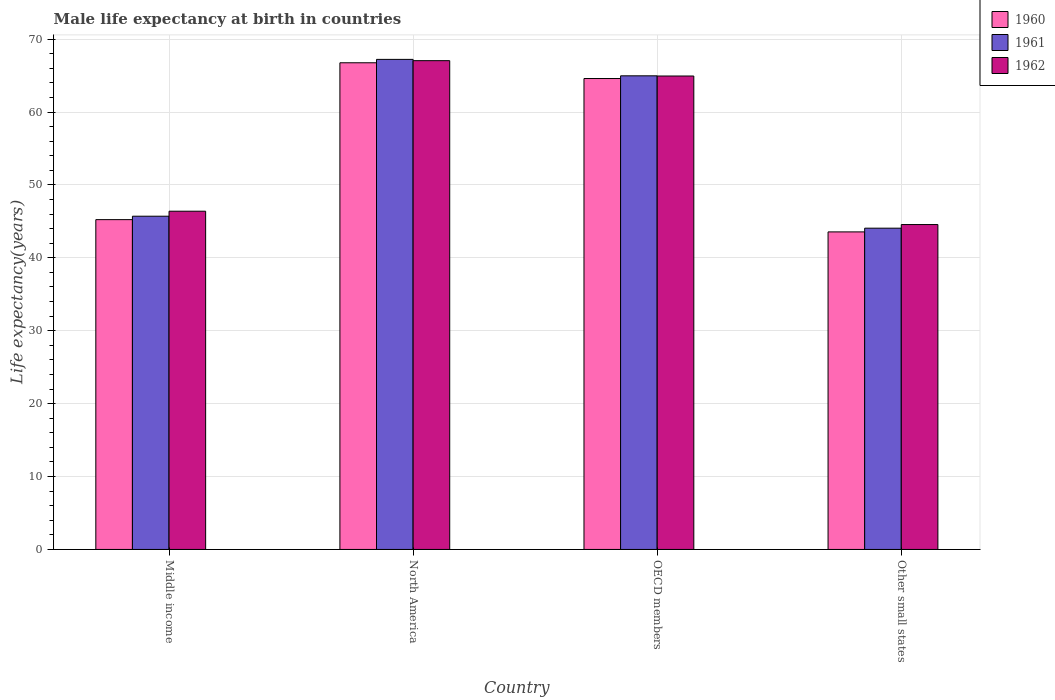How many groups of bars are there?
Make the answer very short. 4. Are the number of bars on each tick of the X-axis equal?
Provide a succinct answer. Yes. How many bars are there on the 1st tick from the left?
Ensure brevity in your answer.  3. How many bars are there on the 4th tick from the right?
Offer a very short reply. 3. What is the label of the 4th group of bars from the left?
Your answer should be very brief. Other small states. What is the male life expectancy at birth in 1961 in OECD members?
Offer a terse response. 64.96. Across all countries, what is the maximum male life expectancy at birth in 1960?
Make the answer very short. 66.75. Across all countries, what is the minimum male life expectancy at birth in 1961?
Your response must be concise. 44.07. In which country was the male life expectancy at birth in 1962 maximum?
Your response must be concise. North America. In which country was the male life expectancy at birth in 1962 minimum?
Provide a short and direct response. Other small states. What is the total male life expectancy at birth in 1960 in the graph?
Your response must be concise. 220.14. What is the difference between the male life expectancy at birth in 1961 in Middle income and that in OECD members?
Provide a short and direct response. -19.26. What is the difference between the male life expectancy at birth in 1961 in North America and the male life expectancy at birth in 1962 in Other small states?
Your answer should be compact. 22.66. What is the average male life expectancy at birth in 1962 per country?
Offer a terse response. 55.73. What is the difference between the male life expectancy at birth of/in 1961 and male life expectancy at birth of/in 1960 in OECD members?
Provide a succinct answer. 0.37. In how many countries, is the male life expectancy at birth in 1961 greater than 30 years?
Give a very brief answer. 4. What is the ratio of the male life expectancy at birth in 1960 in Middle income to that in OECD members?
Make the answer very short. 0.7. Is the difference between the male life expectancy at birth in 1961 in Middle income and Other small states greater than the difference between the male life expectancy at birth in 1960 in Middle income and Other small states?
Your answer should be compact. No. What is the difference between the highest and the second highest male life expectancy at birth in 1961?
Your response must be concise. -2.25. What is the difference between the highest and the lowest male life expectancy at birth in 1961?
Offer a terse response. 23.15. In how many countries, is the male life expectancy at birth in 1960 greater than the average male life expectancy at birth in 1960 taken over all countries?
Your answer should be compact. 2. Is the sum of the male life expectancy at birth in 1962 in North America and OECD members greater than the maximum male life expectancy at birth in 1960 across all countries?
Your response must be concise. Yes. What does the 3rd bar from the right in Middle income represents?
Provide a succinct answer. 1960. Is it the case that in every country, the sum of the male life expectancy at birth in 1961 and male life expectancy at birth in 1962 is greater than the male life expectancy at birth in 1960?
Make the answer very short. Yes. Are all the bars in the graph horizontal?
Provide a short and direct response. No. What is the difference between two consecutive major ticks on the Y-axis?
Offer a terse response. 10. Does the graph contain grids?
Offer a terse response. Yes. Where does the legend appear in the graph?
Your response must be concise. Top right. How many legend labels are there?
Make the answer very short. 3. What is the title of the graph?
Provide a succinct answer. Male life expectancy at birth in countries. What is the label or title of the X-axis?
Keep it short and to the point. Country. What is the label or title of the Y-axis?
Your response must be concise. Life expectancy(years). What is the Life expectancy(years) in 1960 in Middle income?
Provide a short and direct response. 45.24. What is the Life expectancy(years) of 1961 in Middle income?
Offer a terse response. 45.71. What is the Life expectancy(years) of 1962 in Middle income?
Your answer should be compact. 46.39. What is the Life expectancy(years) in 1960 in North America?
Keep it short and to the point. 66.75. What is the Life expectancy(years) in 1961 in North America?
Offer a terse response. 67.22. What is the Life expectancy(years) of 1962 in North America?
Your answer should be very brief. 67.04. What is the Life expectancy(years) in 1960 in OECD members?
Offer a very short reply. 64.59. What is the Life expectancy(years) in 1961 in OECD members?
Ensure brevity in your answer.  64.96. What is the Life expectancy(years) of 1962 in OECD members?
Make the answer very short. 64.94. What is the Life expectancy(years) of 1960 in Other small states?
Provide a succinct answer. 43.56. What is the Life expectancy(years) of 1961 in Other small states?
Ensure brevity in your answer.  44.07. What is the Life expectancy(years) in 1962 in Other small states?
Offer a terse response. 44.56. Across all countries, what is the maximum Life expectancy(years) in 1960?
Provide a succinct answer. 66.75. Across all countries, what is the maximum Life expectancy(years) of 1961?
Offer a terse response. 67.22. Across all countries, what is the maximum Life expectancy(years) in 1962?
Your response must be concise. 67.04. Across all countries, what is the minimum Life expectancy(years) of 1960?
Keep it short and to the point. 43.56. Across all countries, what is the minimum Life expectancy(years) of 1961?
Offer a very short reply. 44.07. Across all countries, what is the minimum Life expectancy(years) in 1962?
Offer a terse response. 44.56. What is the total Life expectancy(years) of 1960 in the graph?
Your answer should be very brief. 220.14. What is the total Life expectancy(years) of 1961 in the graph?
Provide a short and direct response. 221.96. What is the total Life expectancy(years) of 1962 in the graph?
Give a very brief answer. 222.94. What is the difference between the Life expectancy(years) in 1960 in Middle income and that in North America?
Provide a succinct answer. -21.51. What is the difference between the Life expectancy(years) in 1961 in Middle income and that in North America?
Provide a succinct answer. -21.51. What is the difference between the Life expectancy(years) in 1962 in Middle income and that in North America?
Your response must be concise. -20.65. What is the difference between the Life expectancy(years) in 1960 in Middle income and that in OECD members?
Keep it short and to the point. -19.35. What is the difference between the Life expectancy(years) in 1961 in Middle income and that in OECD members?
Provide a succinct answer. -19.26. What is the difference between the Life expectancy(years) in 1962 in Middle income and that in OECD members?
Make the answer very short. -18.54. What is the difference between the Life expectancy(years) of 1960 in Middle income and that in Other small states?
Offer a very short reply. 1.68. What is the difference between the Life expectancy(years) of 1961 in Middle income and that in Other small states?
Offer a terse response. 1.64. What is the difference between the Life expectancy(years) in 1962 in Middle income and that in Other small states?
Offer a terse response. 1.83. What is the difference between the Life expectancy(years) of 1960 in North America and that in OECD members?
Offer a terse response. 2.16. What is the difference between the Life expectancy(years) of 1961 in North America and that in OECD members?
Provide a short and direct response. 2.25. What is the difference between the Life expectancy(years) in 1962 in North America and that in OECD members?
Provide a short and direct response. 2.11. What is the difference between the Life expectancy(years) in 1960 in North America and that in Other small states?
Provide a succinct answer. 23.2. What is the difference between the Life expectancy(years) of 1961 in North America and that in Other small states?
Give a very brief answer. 23.15. What is the difference between the Life expectancy(years) of 1962 in North America and that in Other small states?
Give a very brief answer. 22.48. What is the difference between the Life expectancy(years) of 1960 in OECD members and that in Other small states?
Offer a terse response. 21.04. What is the difference between the Life expectancy(years) in 1961 in OECD members and that in Other small states?
Offer a terse response. 20.9. What is the difference between the Life expectancy(years) of 1962 in OECD members and that in Other small states?
Ensure brevity in your answer.  20.38. What is the difference between the Life expectancy(years) of 1960 in Middle income and the Life expectancy(years) of 1961 in North America?
Offer a very short reply. -21.98. What is the difference between the Life expectancy(years) in 1960 in Middle income and the Life expectancy(years) in 1962 in North America?
Make the answer very short. -21.8. What is the difference between the Life expectancy(years) in 1961 in Middle income and the Life expectancy(years) in 1962 in North America?
Keep it short and to the point. -21.34. What is the difference between the Life expectancy(years) of 1960 in Middle income and the Life expectancy(years) of 1961 in OECD members?
Your answer should be compact. -19.72. What is the difference between the Life expectancy(years) in 1960 in Middle income and the Life expectancy(years) in 1962 in OECD members?
Provide a short and direct response. -19.7. What is the difference between the Life expectancy(years) in 1961 in Middle income and the Life expectancy(years) in 1962 in OECD members?
Keep it short and to the point. -19.23. What is the difference between the Life expectancy(years) in 1960 in Middle income and the Life expectancy(years) in 1961 in Other small states?
Provide a succinct answer. 1.17. What is the difference between the Life expectancy(years) of 1960 in Middle income and the Life expectancy(years) of 1962 in Other small states?
Your response must be concise. 0.68. What is the difference between the Life expectancy(years) in 1961 in Middle income and the Life expectancy(years) in 1962 in Other small states?
Ensure brevity in your answer.  1.14. What is the difference between the Life expectancy(years) in 1960 in North America and the Life expectancy(years) in 1961 in OECD members?
Your answer should be compact. 1.79. What is the difference between the Life expectancy(years) of 1960 in North America and the Life expectancy(years) of 1962 in OECD members?
Keep it short and to the point. 1.82. What is the difference between the Life expectancy(years) in 1961 in North America and the Life expectancy(years) in 1962 in OECD members?
Offer a very short reply. 2.28. What is the difference between the Life expectancy(years) of 1960 in North America and the Life expectancy(years) of 1961 in Other small states?
Give a very brief answer. 22.69. What is the difference between the Life expectancy(years) in 1960 in North America and the Life expectancy(years) in 1962 in Other small states?
Make the answer very short. 22.19. What is the difference between the Life expectancy(years) of 1961 in North America and the Life expectancy(years) of 1962 in Other small states?
Keep it short and to the point. 22.66. What is the difference between the Life expectancy(years) in 1960 in OECD members and the Life expectancy(years) in 1961 in Other small states?
Offer a terse response. 20.53. What is the difference between the Life expectancy(years) of 1960 in OECD members and the Life expectancy(years) of 1962 in Other small states?
Offer a terse response. 20.03. What is the difference between the Life expectancy(years) of 1961 in OECD members and the Life expectancy(years) of 1962 in Other small states?
Provide a succinct answer. 20.4. What is the average Life expectancy(years) in 1960 per country?
Make the answer very short. 55.03. What is the average Life expectancy(years) in 1961 per country?
Your answer should be very brief. 55.49. What is the average Life expectancy(years) in 1962 per country?
Your answer should be compact. 55.73. What is the difference between the Life expectancy(years) in 1960 and Life expectancy(years) in 1961 in Middle income?
Keep it short and to the point. -0.47. What is the difference between the Life expectancy(years) in 1960 and Life expectancy(years) in 1962 in Middle income?
Keep it short and to the point. -1.15. What is the difference between the Life expectancy(years) of 1961 and Life expectancy(years) of 1962 in Middle income?
Offer a very short reply. -0.69. What is the difference between the Life expectancy(years) in 1960 and Life expectancy(years) in 1961 in North America?
Offer a very short reply. -0.47. What is the difference between the Life expectancy(years) in 1960 and Life expectancy(years) in 1962 in North America?
Give a very brief answer. -0.29. What is the difference between the Life expectancy(years) of 1961 and Life expectancy(years) of 1962 in North America?
Your response must be concise. 0.18. What is the difference between the Life expectancy(years) in 1960 and Life expectancy(years) in 1961 in OECD members?
Make the answer very short. -0.37. What is the difference between the Life expectancy(years) in 1960 and Life expectancy(years) in 1962 in OECD members?
Your answer should be very brief. -0.34. What is the difference between the Life expectancy(years) of 1961 and Life expectancy(years) of 1962 in OECD members?
Your answer should be compact. 0.03. What is the difference between the Life expectancy(years) of 1960 and Life expectancy(years) of 1961 in Other small states?
Give a very brief answer. -0.51. What is the difference between the Life expectancy(years) in 1960 and Life expectancy(years) in 1962 in Other small states?
Provide a succinct answer. -1.01. What is the difference between the Life expectancy(years) of 1961 and Life expectancy(years) of 1962 in Other small states?
Offer a terse response. -0.5. What is the ratio of the Life expectancy(years) in 1960 in Middle income to that in North America?
Your answer should be compact. 0.68. What is the ratio of the Life expectancy(years) in 1961 in Middle income to that in North America?
Your answer should be compact. 0.68. What is the ratio of the Life expectancy(years) of 1962 in Middle income to that in North America?
Provide a short and direct response. 0.69. What is the ratio of the Life expectancy(years) in 1960 in Middle income to that in OECD members?
Make the answer very short. 0.7. What is the ratio of the Life expectancy(years) of 1961 in Middle income to that in OECD members?
Offer a very short reply. 0.7. What is the ratio of the Life expectancy(years) in 1962 in Middle income to that in OECD members?
Your answer should be compact. 0.71. What is the ratio of the Life expectancy(years) in 1960 in Middle income to that in Other small states?
Ensure brevity in your answer.  1.04. What is the ratio of the Life expectancy(years) of 1961 in Middle income to that in Other small states?
Give a very brief answer. 1.04. What is the ratio of the Life expectancy(years) of 1962 in Middle income to that in Other small states?
Provide a short and direct response. 1.04. What is the ratio of the Life expectancy(years) in 1960 in North America to that in OECD members?
Ensure brevity in your answer.  1.03. What is the ratio of the Life expectancy(years) of 1961 in North America to that in OECD members?
Offer a very short reply. 1.03. What is the ratio of the Life expectancy(years) of 1962 in North America to that in OECD members?
Provide a short and direct response. 1.03. What is the ratio of the Life expectancy(years) in 1960 in North America to that in Other small states?
Offer a very short reply. 1.53. What is the ratio of the Life expectancy(years) of 1961 in North America to that in Other small states?
Provide a short and direct response. 1.53. What is the ratio of the Life expectancy(years) of 1962 in North America to that in Other small states?
Make the answer very short. 1.5. What is the ratio of the Life expectancy(years) in 1960 in OECD members to that in Other small states?
Your answer should be compact. 1.48. What is the ratio of the Life expectancy(years) of 1961 in OECD members to that in Other small states?
Make the answer very short. 1.47. What is the ratio of the Life expectancy(years) of 1962 in OECD members to that in Other small states?
Your response must be concise. 1.46. What is the difference between the highest and the second highest Life expectancy(years) in 1960?
Give a very brief answer. 2.16. What is the difference between the highest and the second highest Life expectancy(years) in 1961?
Make the answer very short. 2.25. What is the difference between the highest and the second highest Life expectancy(years) of 1962?
Offer a terse response. 2.11. What is the difference between the highest and the lowest Life expectancy(years) in 1960?
Your response must be concise. 23.2. What is the difference between the highest and the lowest Life expectancy(years) of 1961?
Offer a very short reply. 23.15. What is the difference between the highest and the lowest Life expectancy(years) of 1962?
Provide a short and direct response. 22.48. 